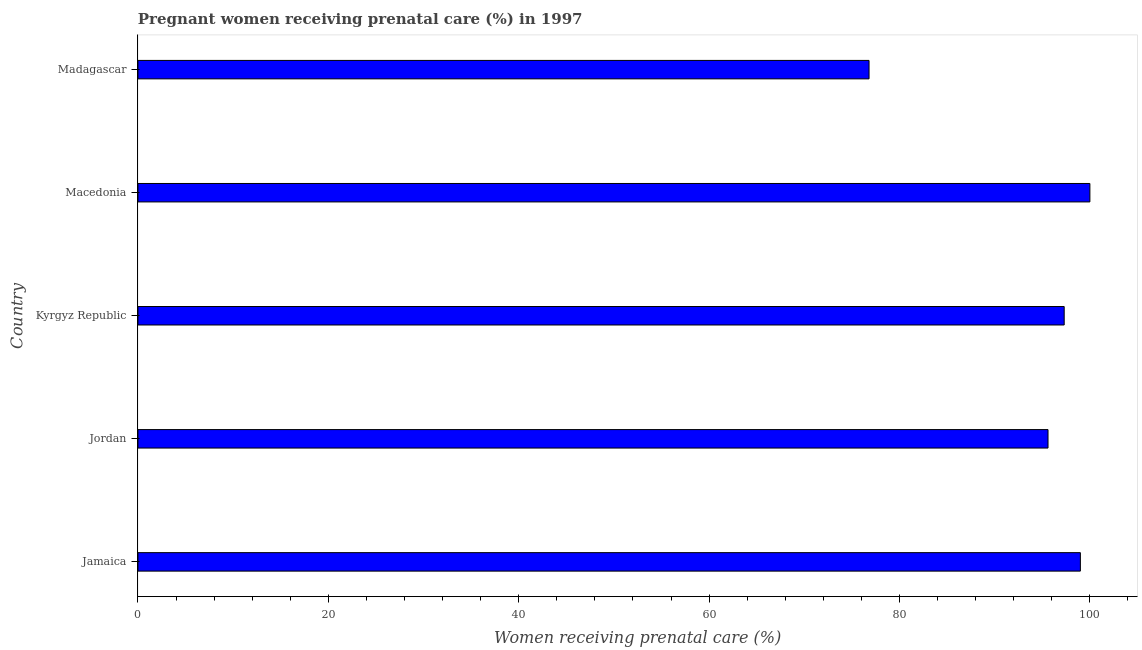Does the graph contain any zero values?
Give a very brief answer. No. What is the title of the graph?
Offer a very short reply. Pregnant women receiving prenatal care (%) in 1997. What is the label or title of the X-axis?
Your answer should be very brief. Women receiving prenatal care (%). What is the label or title of the Y-axis?
Give a very brief answer. Country. What is the percentage of pregnant women receiving prenatal care in Jamaica?
Provide a succinct answer. 99. Across all countries, what is the minimum percentage of pregnant women receiving prenatal care?
Provide a short and direct response. 76.8. In which country was the percentage of pregnant women receiving prenatal care maximum?
Give a very brief answer. Macedonia. In which country was the percentage of pregnant women receiving prenatal care minimum?
Ensure brevity in your answer.  Madagascar. What is the sum of the percentage of pregnant women receiving prenatal care?
Provide a short and direct response. 468.7. What is the average percentage of pregnant women receiving prenatal care per country?
Make the answer very short. 93.74. What is the median percentage of pregnant women receiving prenatal care?
Provide a succinct answer. 97.3. In how many countries, is the percentage of pregnant women receiving prenatal care greater than 28 %?
Ensure brevity in your answer.  5. What is the ratio of the percentage of pregnant women receiving prenatal care in Jamaica to that in Jordan?
Give a very brief answer. 1.04. Is the difference between the percentage of pregnant women receiving prenatal care in Jordan and Kyrgyz Republic greater than the difference between any two countries?
Make the answer very short. No. What is the difference between the highest and the second highest percentage of pregnant women receiving prenatal care?
Make the answer very short. 1. What is the difference between the highest and the lowest percentage of pregnant women receiving prenatal care?
Provide a succinct answer. 23.2. In how many countries, is the percentage of pregnant women receiving prenatal care greater than the average percentage of pregnant women receiving prenatal care taken over all countries?
Provide a short and direct response. 4. What is the difference between two consecutive major ticks on the X-axis?
Keep it short and to the point. 20. Are the values on the major ticks of X-axis written in scientific E-notation?
Offer a very short reply. No. What is the Women receiving prenatal care (%) of Jordan?
Provide a short and direct response. 95.6. What is the Women receiving prenatal care (%) of Kyrgyz Republic?
Provide a succinct answer. 97.3. What is the Women receiving prenatal care (%) in Macedonia?
Provide a short and direct response. 100. What is the Women receiving prenatal care (%) in Madagascar?
Offer a very short reply. 76.8. What is the difference between the Women receiving prenatal care (%) in Jamaica and Macedonia?
Your response must be concise. -1. What is the difference between the Women receiving prenatal care (%) in Jamaica and Madagascar?
Offer a terse response. 22.2. What is the difference between the Women receiving prenatal care (%) in Kyrgyz Republic and Madagascar?
Your answer should be compact. 20.5. What is the difference between the Women receiving prenatal care (%) in Macedonia and Madagascar?
Offer a terse response. 23.2. What is the ratio of the Women receiving prenatal care (%) in Jamaica to that in Jordan?
Provide a succinct answer. 1.04. What is the ratio of the Women receiving prenatal care (%) in Jamaica to that in Macedonia?
Make the answer very short. 0.99. What is the ratio of the Women receiving prenatal care (%) in Jamaica to that in Madagascar?
Give a very brief answer. 1.29. What is the ratio of the Women receiving prenatal care (%) in Jordan to that in Macedonia?
Provide a short and direct response. 0.96. What is the ratio of the Women receiving prenatal care (%) in Jordan to that in Madagascar?
Give a very brief answer. 1.25. What is the ratio of the Women receiving prenatal care (%) in Kyrgyz Republic to that in Macedonia?
Keep it short and to the point. 0.97. What is the ratio of the Women receiving prenatal care (%) in Kyrgyz Republic to that in Madagascar?
Your answer should be compact. 1.27. What is the ratio of the Women receiving prenatal care (%) in Macedonia to that in Madagascar?
Keep it short and to the point. 1.3. 